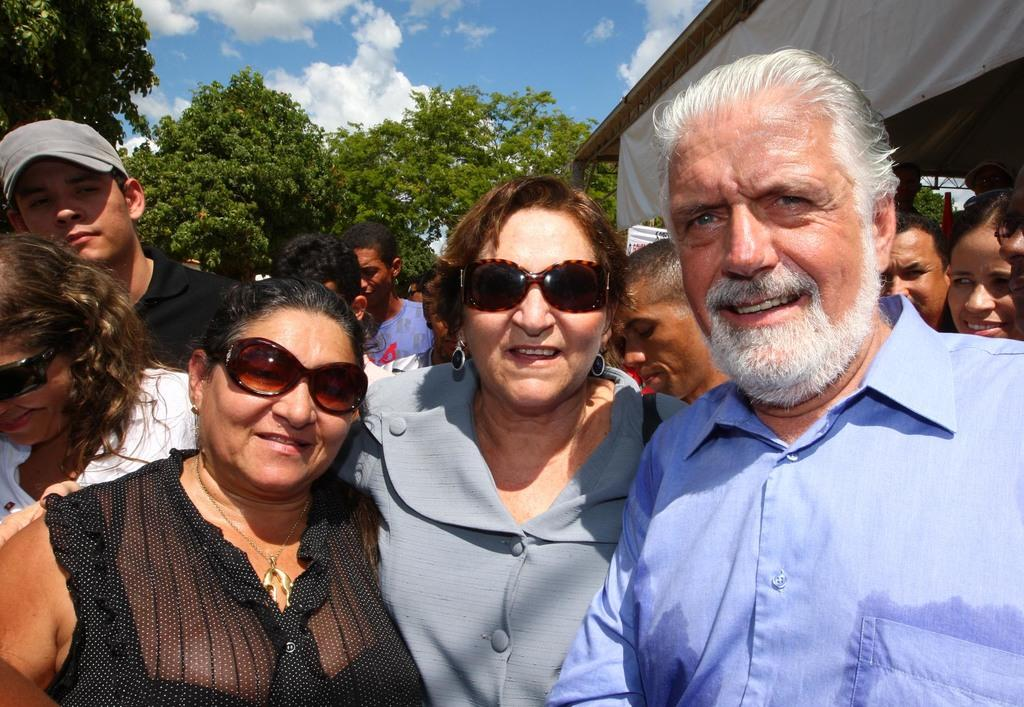What structure is present in the image? There is a shed in the image. What are the people in the image doing? There is a group of people standing in front of the shed. What type of vegetation can be seen in the image? There are trees visible at the back of the image. What is the condition of the sky in the image? The sky is cloudy and visible at the top of the image. Can you tell me how many ants are crawling on the shed in the image? There are no ants visible on the shed in the image. What type of walk is the group of people doing in front of the shed? There is no indication of a specific type of walk in the image; the group of people is simply standing in front of the shed. 